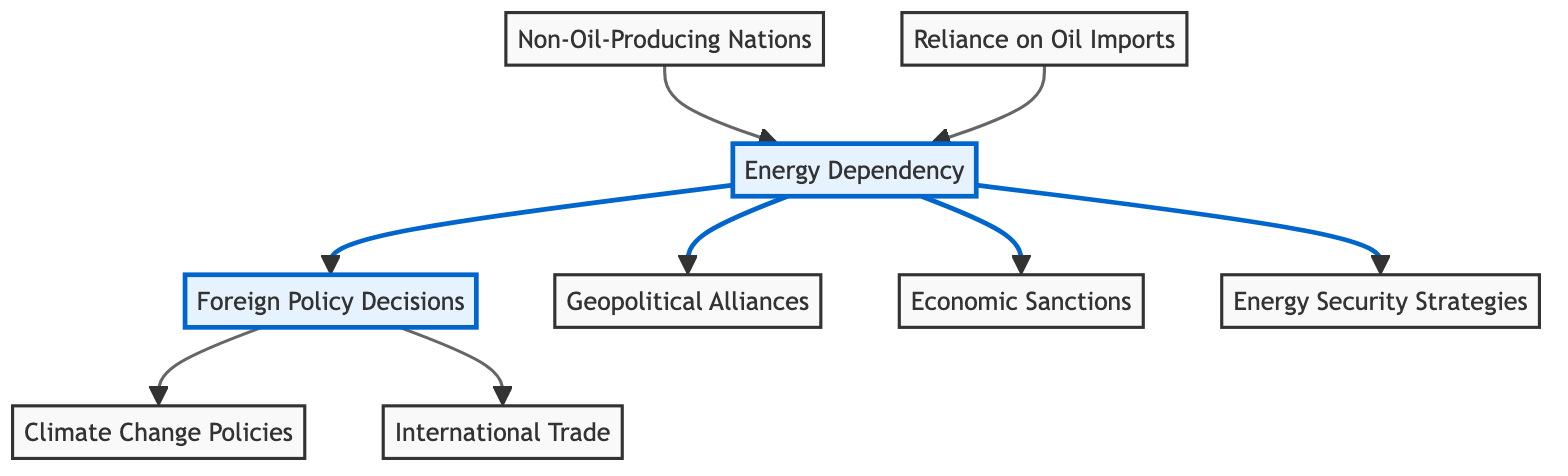What is the source node for the "Energy Dependency"? The diagram illustrates that "Non-Oil-Producing Nations" and "Reliance on Oil Imports" both point to "Energy Dependency," making them the source nodes that influence this concept.
Answer: Non-Oil-Producing Nations, Reliance on Oil Imports How many edges are there in the diagram? Counting the connections drawn between the nodes reveals there are 8 edges in total connecting various concepts illustrated in the diagram.
Answer: 8 What nodes are influenced by "Energy Dependency"? The diagram shows that "Energy Dependency" has outgoing links to four different nodes: "Foreign Policy Decisions," "Geopolitical Alliances," "Economic Sanctions," and "Energy Security Strategies."
Answer: Foreign Policy Decisions, Geopolitical Alliances, Economic Sanctions, Energy Security Strategies Which node has no outgoing connections? Evaluating the diagram, "International Trade" stands out because it does not have any directed edges leading to other nodes, indicating that it is not directly influenced by any other concept shown.
Answer: International Trade What is the relationship between "Foreign Policy Decisions" and "Climate Change Policies"? The diagram depicts a direct connection from "Foreign Policy Decisions" to "Climate Change Policies," indicating that decisions in foreign policy can impact climate policies, suggesting a flow of influence.
Answer: A directed edge exists How does "Reliance on Oil Imports" affect "Energy Dependency"? The diagram illustrates that "Reliance on Oil Imports" directly influences "Energy Dependency," indicating that higher dependency on oil imports contributes to a nation's overall energy dependency status.
Answer: Direct influence What is the significance of "Geopolitical Alliances" in the context of "Energy Dependency"? The diagram indicates that "Geopolitical Alliances" is one of the outcomes of "Energy Dependency," implying that a nation's energy reliance can shape its alliances in the geopolitical landscape.
Answer: Outcome of Energy Dependency What two nodes are influenced by "Foreign Policy Decisions"? "Foreign Policy Decisions" impacts both "Climate Change Policies" and "International Trade," indicating that foreign policy can shape these areas significantly.
Answer: Climate Change Policies, International Trade 